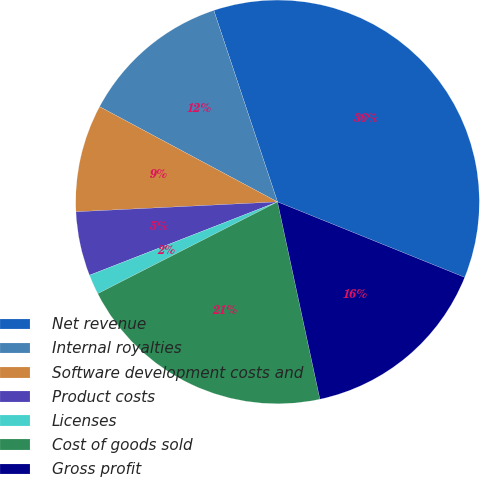<chart> <loc_0><loc_0><loc_500><loc_500><pie_chart><fcel>Net revenue<fcel>Internal royalties<fcel>Software development costs and<fcel>Product costs<fcel>Licenses<fcel>Cost of goods sold<fcel>Gross profit<nl><fcel>36.21%<fcel>12.07%<fcel>8.6%<fcel>5.14%<fcel>1.59%<fcel>20.86%<fcel>15.53%<nl></chart> 